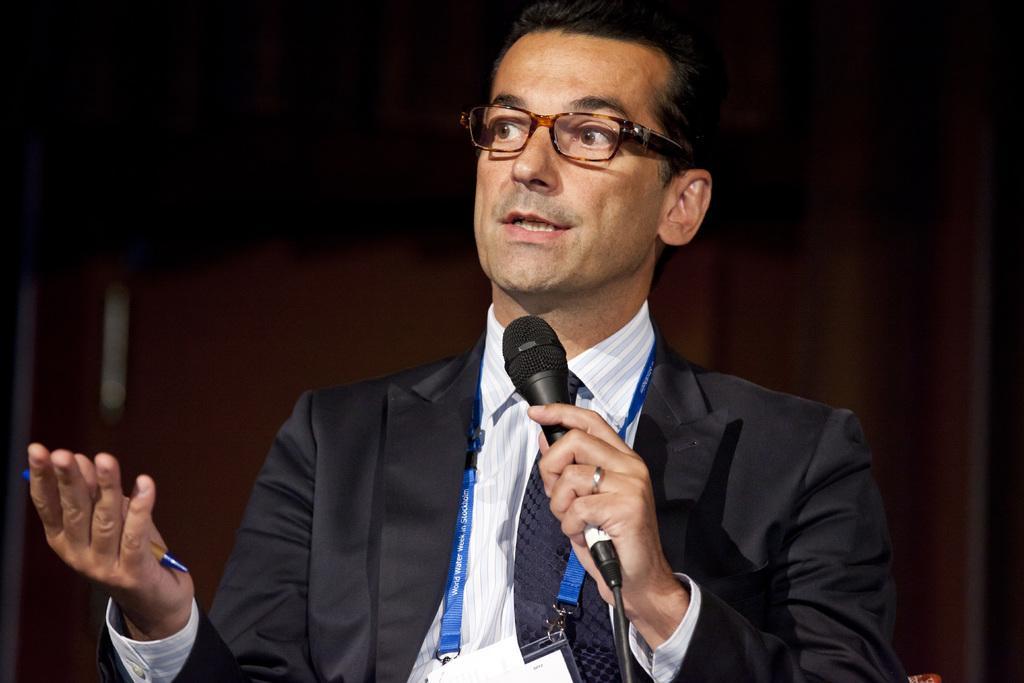How would you summarize this image in a sentence or two? In this picture there is a black coat guy who has a mic in his one his hands and a pen in his other hand. In the background we observe a brown curtain. 